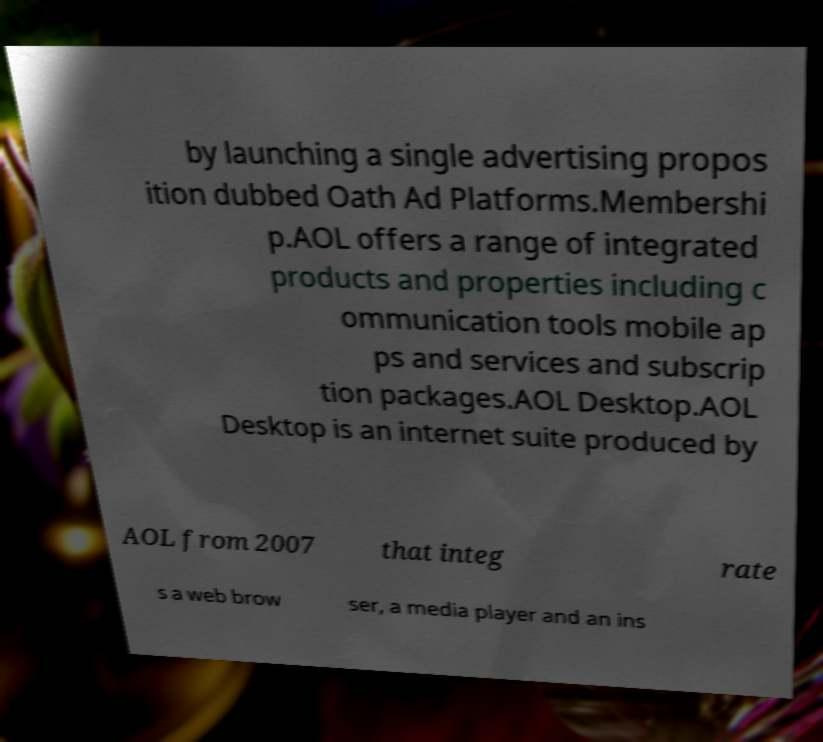Can you read and provide the text displayed in the image?This photo seems to have some interesting text. Can you extract and type it out for me? by launching a single advertising propos ition dubbed Oath Ad Platforms.Membershi p.AOL offers a range of integrated products and properties including c ommunication tools mobile ap ps and services and subscrip tion packages.AOL Desktop.AOL Desktop is an internet suite produced by AOL from 2007 that integ rate s a web brow ser, a media player and an ins 